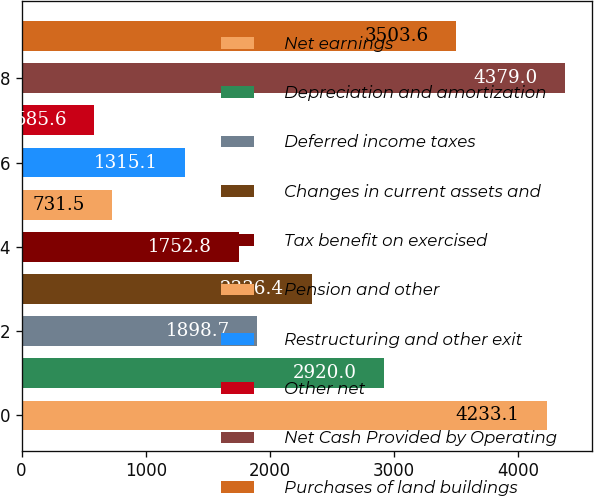Convert chart to OTSL. <chart><loc_0><loc_0><loc_500><loc_500><bar_chart><fcel>Net earnings<fcel>Depreciation and amortization<fcel>Deferred income taxes<fcel>Changes in current assets and<fcel>Tax benefit on exercised<fcel>Pension and other<fcel>Restructuring and other exit<fcel>Other net<fcel>Net Cash Provided by Operating<fcel>Purchases of land buildings<nl><fcel>4233.1<fcel>2920<fcel>1898.7<fcel>2336.4<fcel>1752.8<fcel>731.5<fcel>1315.1<fcel>585.6<fcel>4379<fcel>3503.6<nl></chart> 